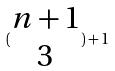<formula> <loc_0><loc_0><loc_500><loc_500>( \begin{matrix} n + 1 \\ 3 \end{matrix} ) + 1</formula> 